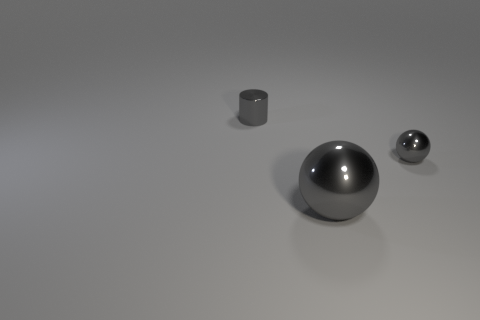Add 3 metallic balls. How many objects exist? 6 Subtract all balls. How many objects are left? 1 Subtract 2 gray spheres. How many objects are left? 1 Subtract all tiny purple cubes. Subtract all large objects. How many objects are left? 2 Add 3 gray metallic objects. How many gray metallic objects are left? 6 Add 3 small shiny objects. How many small shiny objects exist? 5 